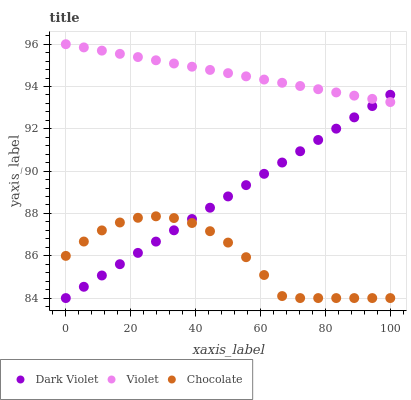Does Chocolate have the minimum area under the curve?
Answer yes or no. Yes. Does Violet have the maximum area under the curve?
Answer yes or no. Yes. Does Dark Violet have the minimum area under the curve?
Answer yes or no. No. Does Dark Violet have the maximum area under the curve?
Answer yes or no. No. Is Violet the smoothest?
Answer yes or no. Yes. Is Chocolate the roughest?
Answer yes or no. Yes. Is Dark Violet the smoothest?
Answer yes or no. No. Is Dark Violet the roughest?
Answer yes or no. No. Does Chocolate have the lowest value?
Answer yes or no. Yes. Does Violet have the lowest value?
Answer yes or no. No. Does Violet have the highest value?
Answer yes or no. Yes. Does Dark Violet have the highest value?
Answer yes or no. No. Is Chocolate less than Violet?
Answer yes or no. Yes. Is Violet greater than Chocolate?
Answer yes or no. Yes. Does Violet intersect Dark Violet?
Answer yes or no. Yes. Is Violet less than Dark Violet?
Answer yes or no. No. Is Violet greater than Dark Violet?
Answer yes or no. No. Does Chocolate intersect Violet?
Answer yes or no. No. 